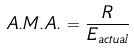Convert formula to latex. <formula><loc_0><loc_0><loc_500><loc_500>A . M . A . = \frac { R } { E _ { a c t u a l } }</formula> 